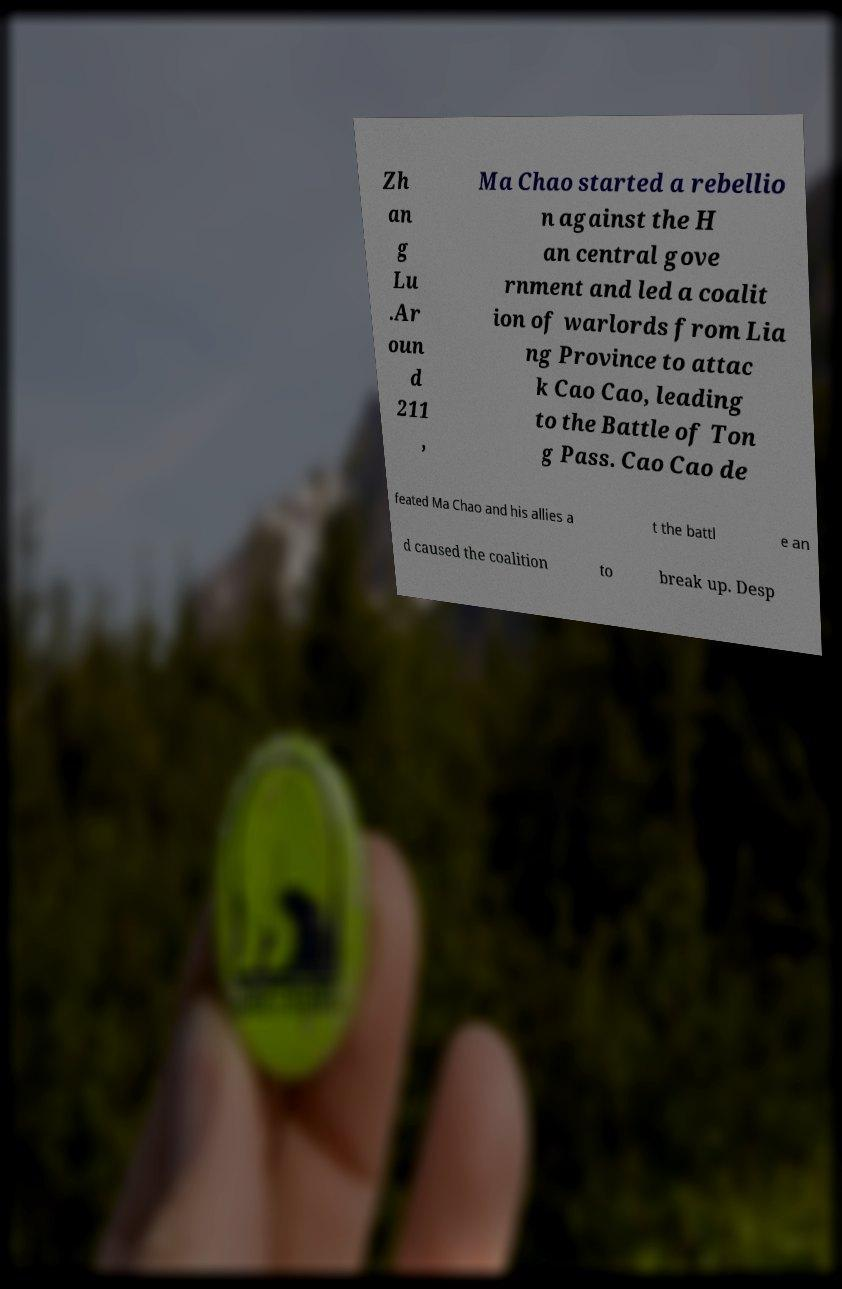For documentation purposes, I need the text within this image transcribed. Could you provide that? Zh an g Lu .Ar oun d 211 , Ma Chao started a rebellio n against the H an central gove rnment and led a coalit ion of warlords from Lia ng Province to attac k Cao Cao, leading to the Battle of Ton g Pass. Cao Cao de feated Ma Chao and his allies a t the battl e an d caused the coalition to break up. Desp 